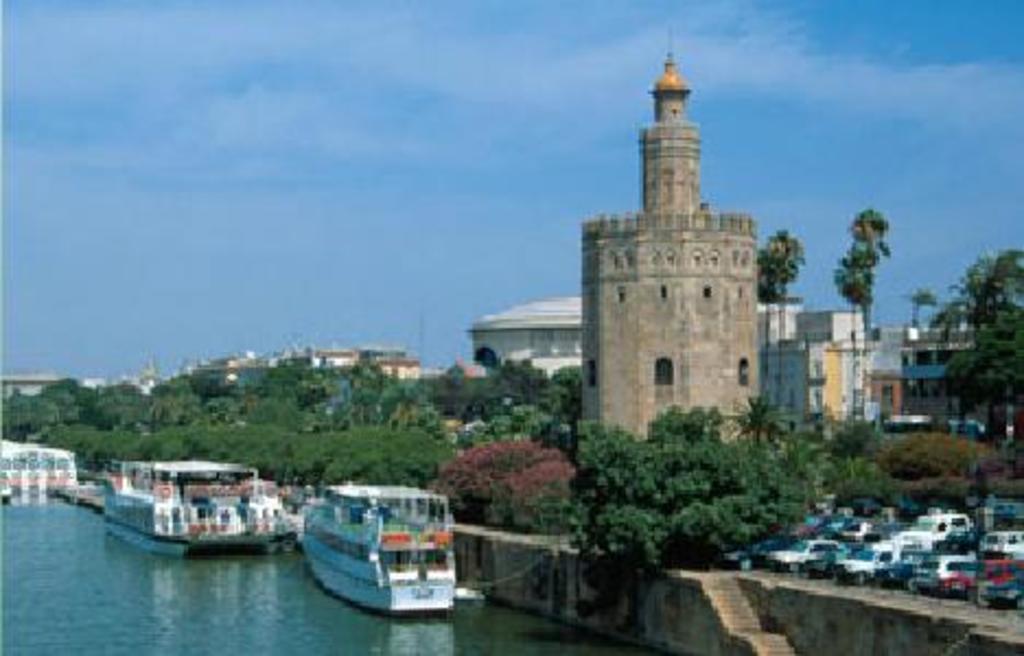How would you summarize this image in a sentence or two? In this image we can see trees, tower, buildings, cars. At the bottom of the image we can see stairs and boats in water. In the background there is sky and ground. 